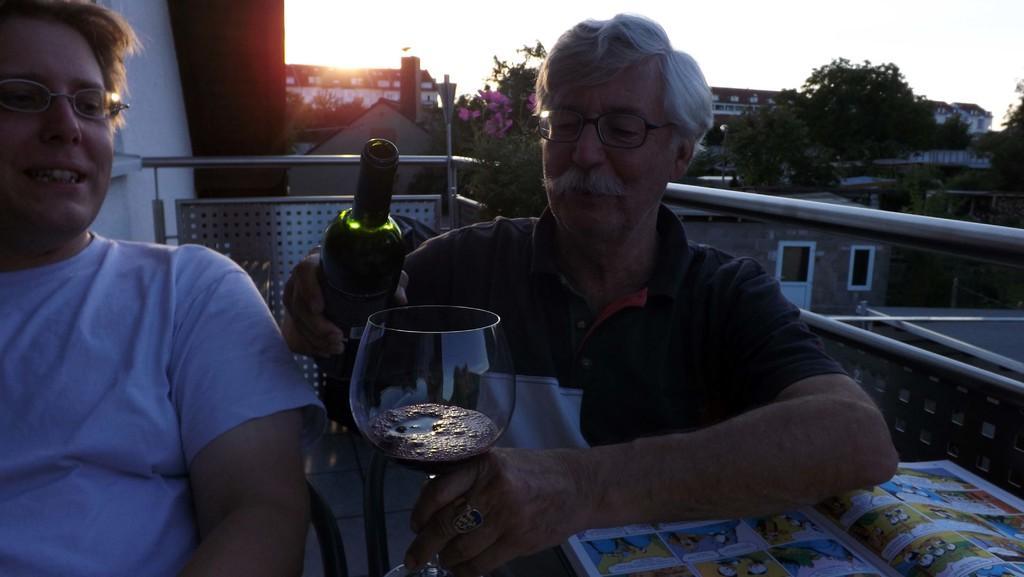Please provide a concise description of this image. In this image I see 2 men sitting and both of them are wearing spectacles and one of the man is holding a bottle in one hand and a glass in another hand and there is a book in front of him. In the background I can see lot of trees, buildings and the sky. 